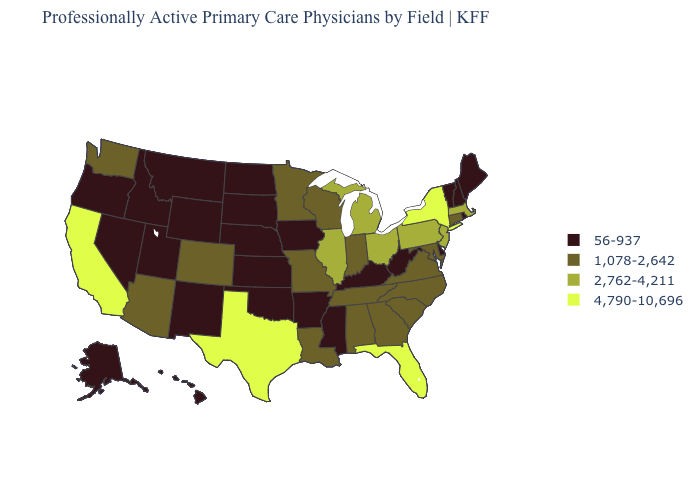What is the value of Kentucky?
Concise answer only. 56-937. How many symbols are there in the legend?
Write a very short answer. 4. What is the value of Iowa?
Be succinct. 56-937. Does Michigan have a lower value than New York?
Be succinct. Yes. What is the value of Massachusetts?
Short answer required. 2,762-4,211. What is the lowest value in the USA?
Give a very brief answer. 56-937. Does California have the highest value in the USA?
Give a very brief answer. Yes. Name the states that have a value in the range 56-937?
Concise answer only. Alaska, Arkansas, Delaware, Hawaii, Idaho, Iowa, Kansas, Kentucky, Maine, Mississippi, Montana, Nebraska, Nevada, New Hampshire, New Mexico, North Dakota, Oklahoma, Oregon, Rhode Island, South Dakota, Utah, Vermont, West Virginia, Wyoming. Does Colorado have the highest value in the USA?
Quick response, please. No. Name the states that have a value in the range 56-937?
Short answer required. Alaska, Arkansas, Delaware, Hawaii, Idaho, Iowa, Kansas, Kentucky, Maine, Mississippi, Montana, Nebraska, Nevada, New Hampshire, New Mexico, North Dakota, Oklahoma, Oregon, Rhode Island, South Dakota, Utah, Vermont, West Virginia, Wyoming. What is the value of Oklahoma?
Short answer required. 56-937. What is the highest value in the South ?
Quick response, please. 4,790-10,696. Does Massachusetts have the same value as Nebraska?
Concise answer only. No. Does Iowa have the lowest value in the MidWest?
Short answer required. Yes. Among the states that border Missouri , which have the lowest value?
Answer briefly. Arkansas, Iowa, Kansas, Kentucky, Nebraska, Oklahoma. 